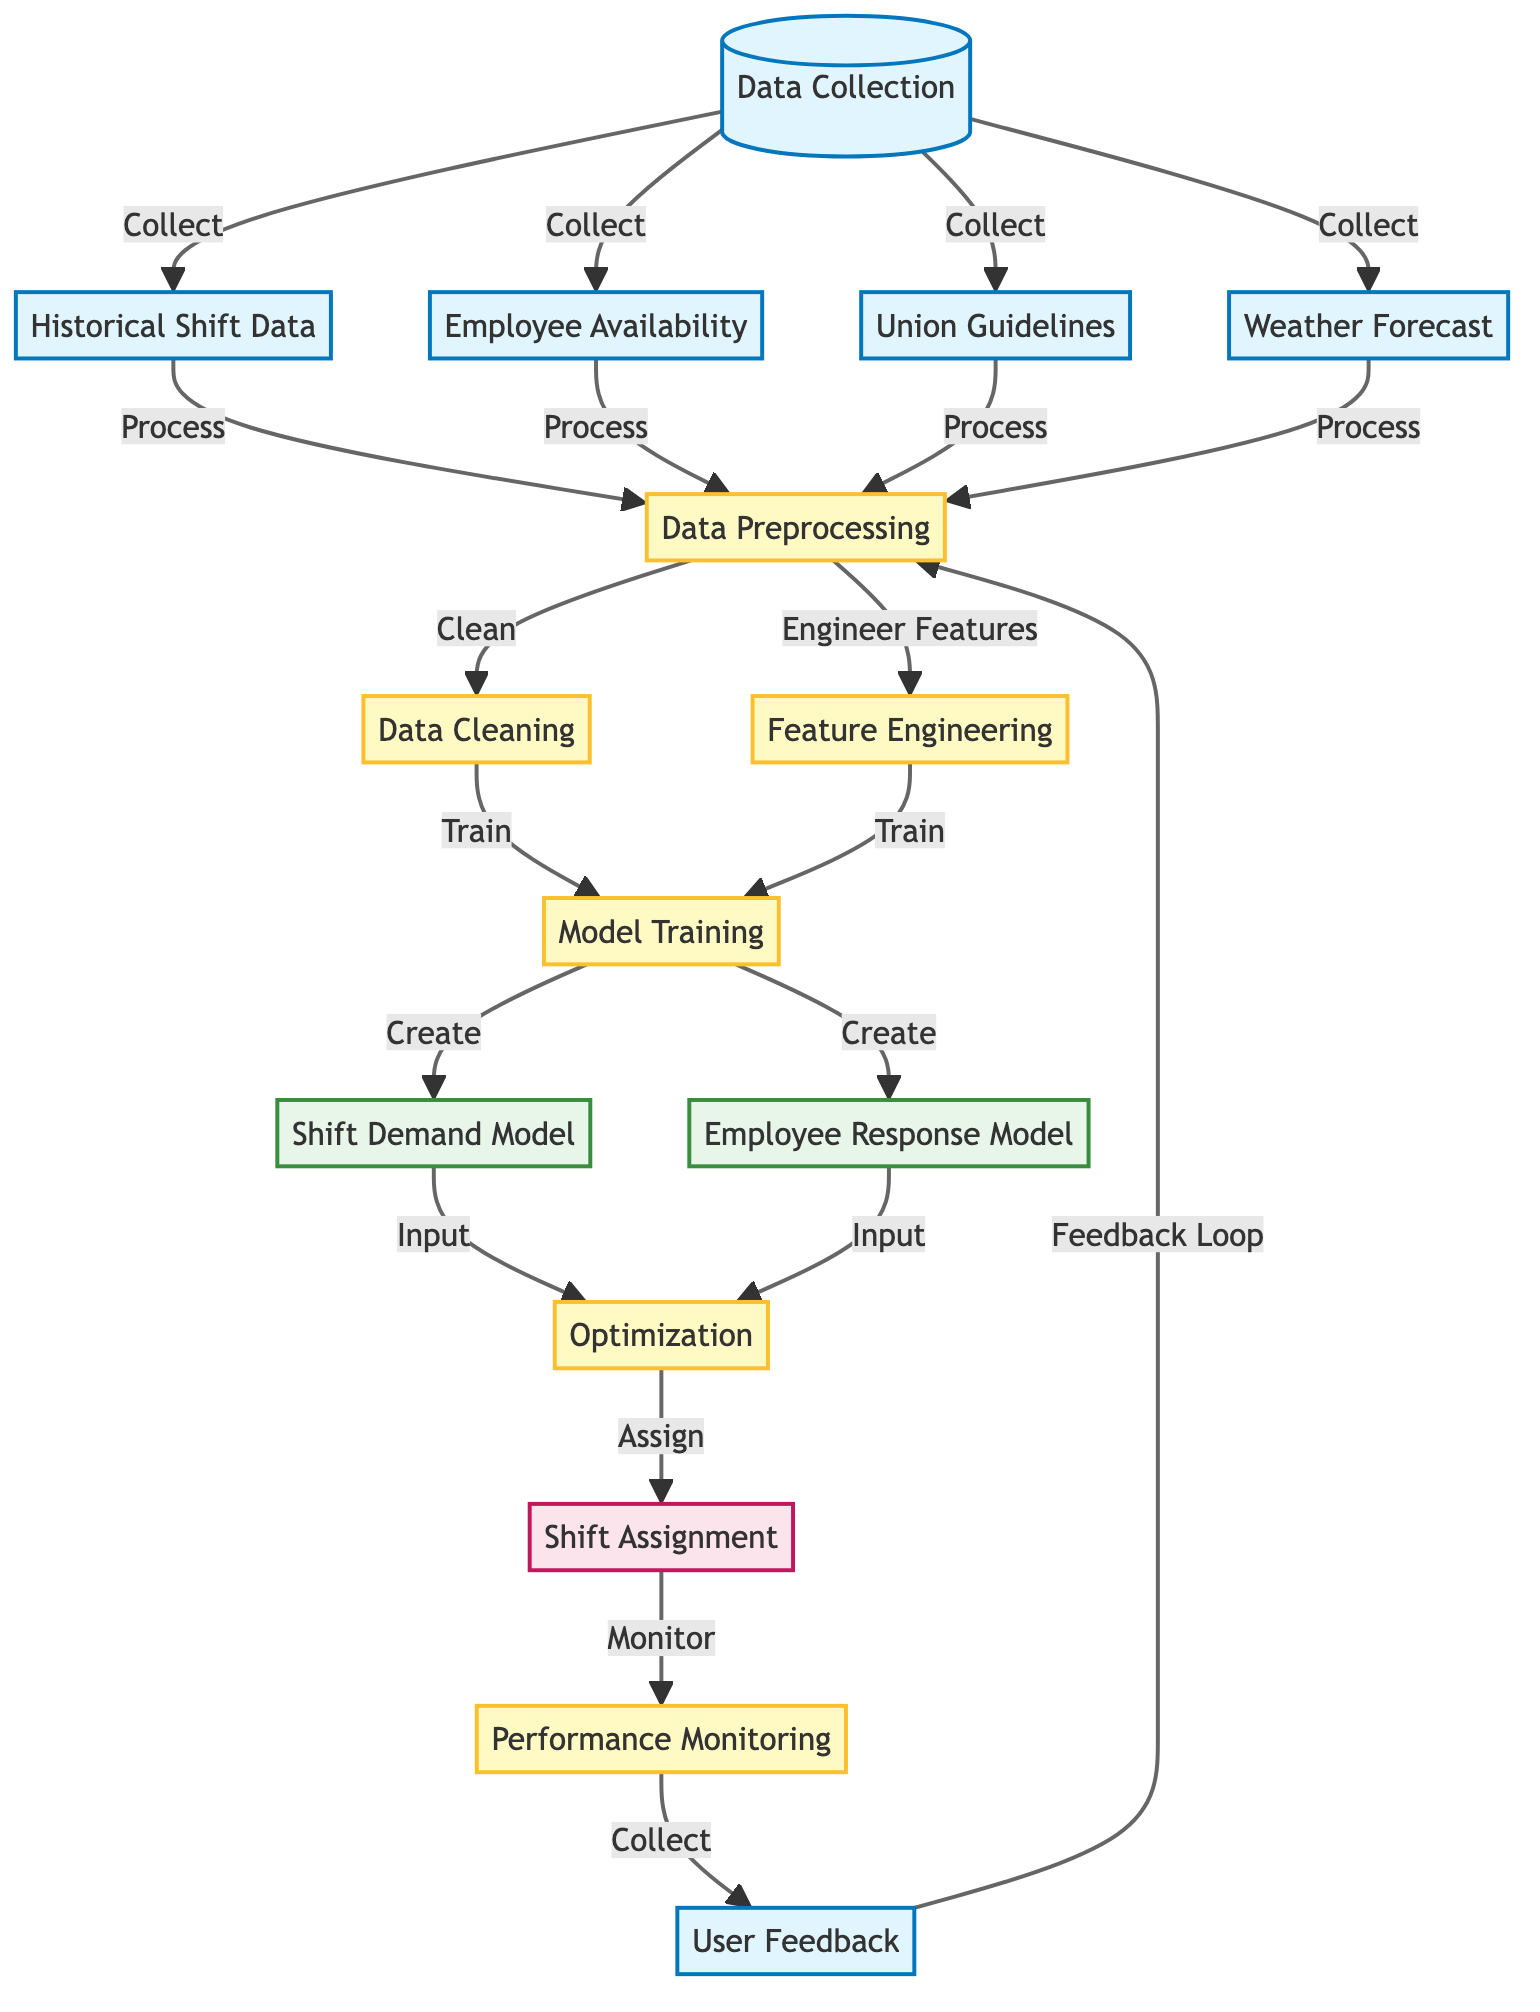What are the four main data inputs in this diagram? The nodes listed as inputs are historical shift data, employee availability, union guidelines, and weather forecast. They are all direct outputs from the data collection node.
Answer: historical shift data, employee availability, union guidelines, weather forecast How many process nodes are there in the diagram? The process nodes are data preprocessing, data cleaning, feature engineering, model training, optimization, and performance monitoring, totaling six process nodes.
Answer: six Which model nodes are created during model training? The diagram specifies that the shift demand model and employee response model are the two model nodes created after model training is completed.
Answer: shift demand model, employee response model What does the shift assignment node depend on? The shift assignment node depends on the optimization node, which integrates information from the two model nodes: shift demand model and employee response model.
Answer: optimization What happens after performance monitoring collects user feedback? The user feedback forms a feedback loop that leads back to the data preprocessing node for ongoing improvements and adjustments based on performance insights.
Answer: data preprocessing What types of models are included in this machine learning diagram? The diagram identifies two types of models: a shift demand model and an employee response model, both resulting from model training.
Answer: shift demand model, employee response model How is data cleaning related to data preprocessing according to the diagram? Data cleaning is a subsequent process that follows data preprocessing; the flow indicates that both data cleaning and feature engineering come after data preprocessing is completed.
Answer: data cleaning Which node is monitored after shift assignment? The diagram indicates that performance monitoring is conducted after the shift assignment node, serving to evaluate how well the shifts are being managed.
Answer: performance monitoring What is the purpose of the optimization node? The optimization node processes inputs from both model nodes and is responsible for assigning shifts to employees based on the models' predictions and data inputs.
Answer: assign shifts 